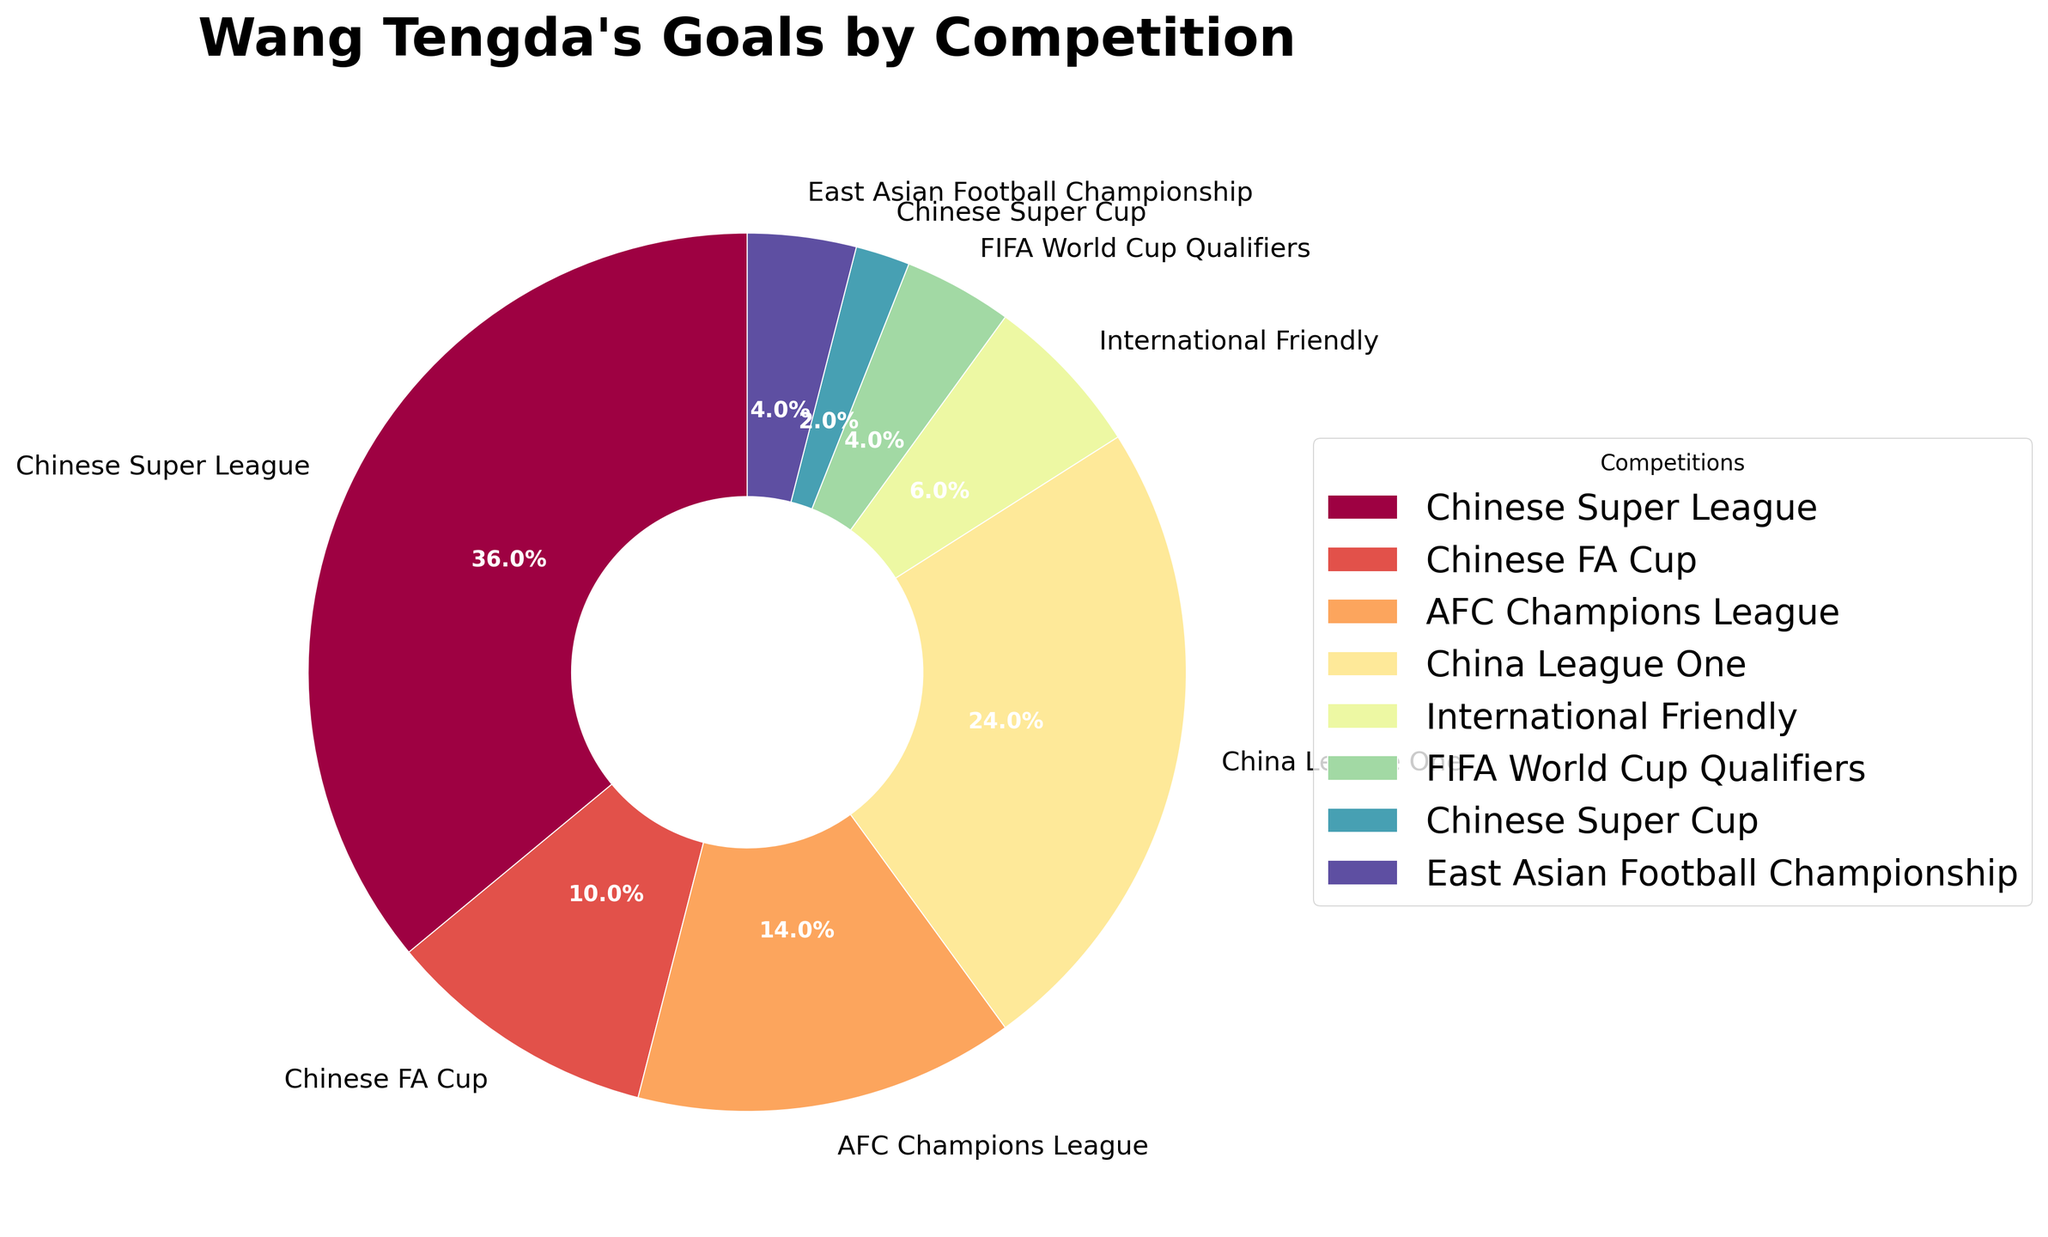How many more goals has Wang Tengda scored in the Chinese Super League than in the AFC Champions League? The Chinese Super League contributes 18 goals and the AFC Champions League contributes 7 goals. Subtract the goals in AFC Champions League from Chinese Super League goals: 18 - 7 = 11
Answer: 11 Which competition has the smallest slice in the pie chart? The smallest slice in the pie chart is the competition with the fewest goals scored. From the data, the Chinese Super Cup has 1 goal, which is the fewest.
Answer: Chinese Super Cup What is the total number of goals scored in the Chinese FA Cup and China League One? Add the goals scored in the Chinese FA Cup (5) and China League One (12): 5 + 12 = 17
Answer: 17 Which competition accounts for the largest percentage of Wang Tengda's total goals? The pie chart shows that the largest slice is for the Chinese Super League, which accounts for the highest percentage of total goals.
Answer: Chinese Super League Compare the number of goals scored in International Friendly and FIFA World Cup Qualifiers. Which is higher? The number of goals scored in International Friendly is 3 and in FIFA World Cup Qualifiers is 2. Comparing these values, International Friendly has more goals.
Answer: International Friendly What percentage of goals did Wang Tengda score in East Asian Football Championship? The pie chart shows the percentage for each competition. East Asian Football Championship has 2 goals out of the total 50 goals. Calculation: (2/50) * 100% = 4%
Answer: 4% How many competitions did Wang Tengda score less than 5 goals in? From the data, count the competitions where the goals are less than 5: International Friendly (3), FIFA World Cup Qualifiers (2), Chinese Super Cup (1), and East Asian Football Championship (2). Four competitions have less than 5 goals.
Answer: 4 What is the difference between the number of goals scored in China League One and International Friendly? Subtract the number of goals in International Friendly (3) from China League One (12): 12 - 3 = 9
Answer: 9 Which two competitions have a combined goal count equal to the AFC Champions League? Combine the goals of different competitions to see which sum equals 7. International Friendly (3) and East Asian Football Championship (2) together do not make 7, but International Friendly (3) and FIFA World Cup Qualifiers (2) also do not make 7, continuing the combinations verifies that FIFA World Cup Qualifiers (2) and Chinese Super Cup (1) do not either, but East Asian Football Championship (2) and FIFA World Cup Qualifiers (2) together do make 7.
Answer: No such two competitions 